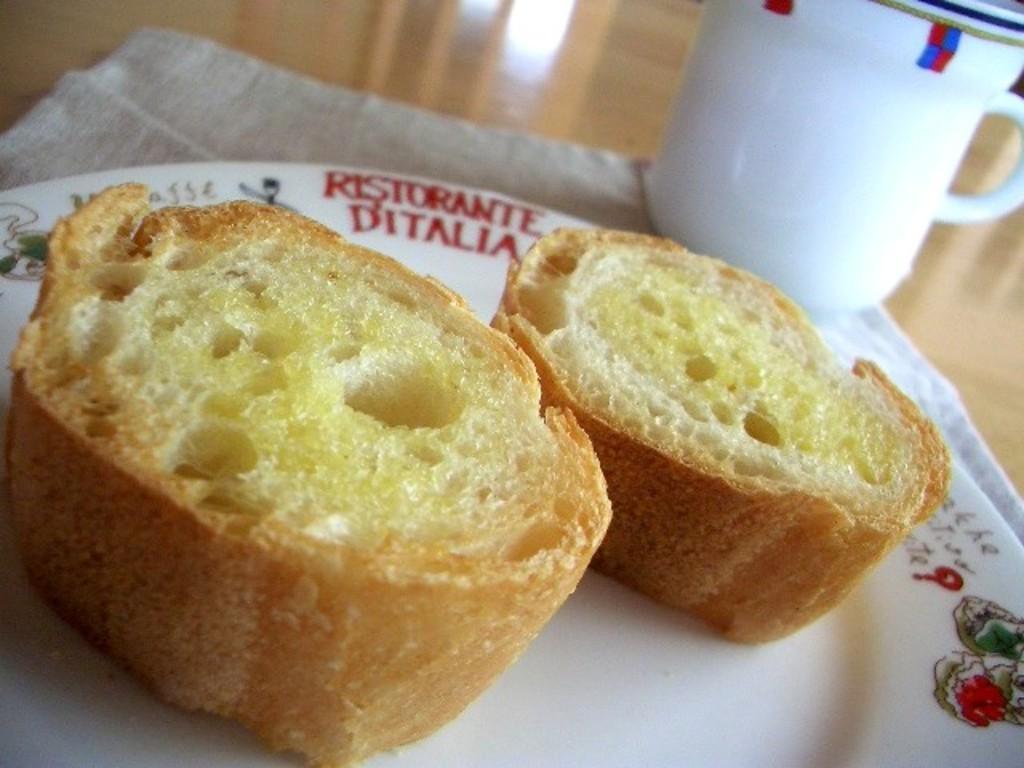Please provide a concise description of this image. In this picture we can see food in the plate, beside to the plate we can find a cup. 